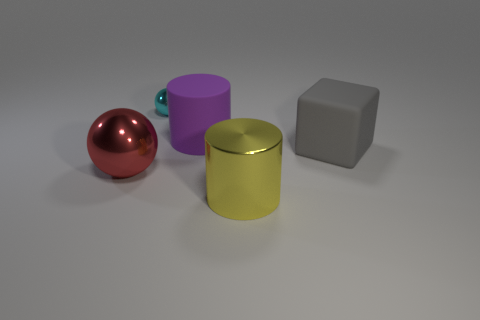Is there a purple rubber object that has the same size as the red metal thing?
Make the answer very short. Yes. What is the shape of the other metallic thing that is the same size as the red metallic object?
Give a very brief answer. Cylinder. Is there a red metallic object of the same shape as the purple thing?
Your answer should be compact. No. Are the large gray block and the cylinder that is in front of the large gray matte block made of the same material?
Offer a very short reply. No. Are there any big shiny blocks that have the same color as the rubber cylinder?
Give a very brief answer. No. What number of other things are made of the same material as the large red ball?
Ensure brevity in your answer.  2. Is the color of the tiny metal object the same as the big cylinder behind the large red shiny thing?
Ensure brevity in your answer.  No. Are there more purple cylinders that are in front of the metal cylinder than large gray matte spheres?
Your answer should be very brief. No. There is a shiny sphere that is in front of the tiny shiny ball that is on the left side of the gray cube; how many shiny cylinders are left of it?
Offer a very short reply. 0. Is the shape of the large matte object behind the large gray object the same as  the gray thing?
Make the answer very short. No. 